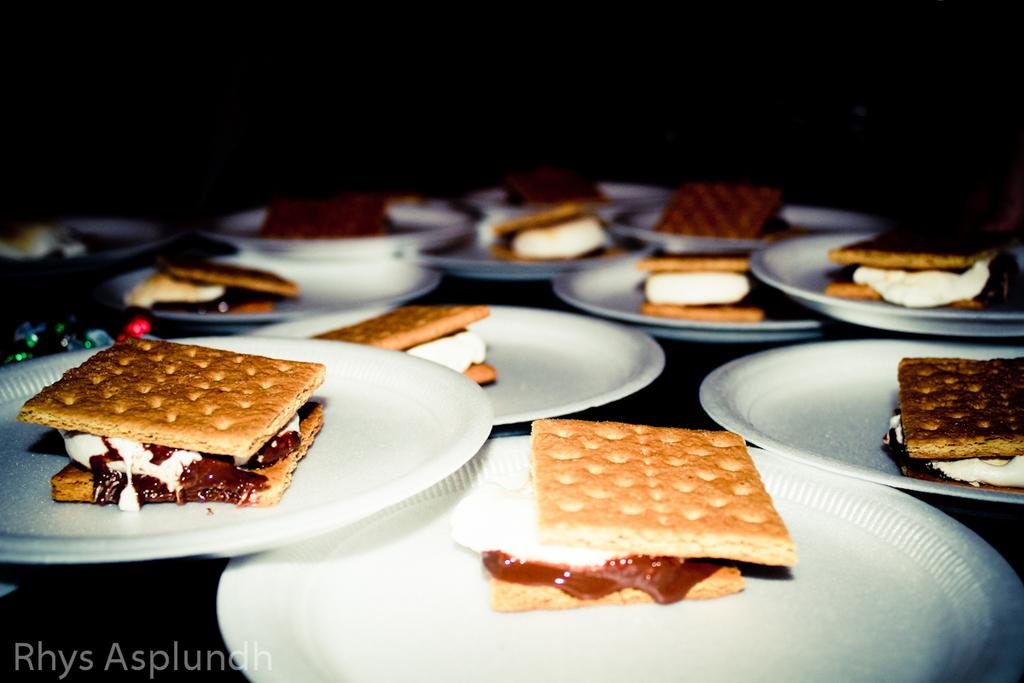What is the main object in the center of the image? There is a table in the center of the image. What is placed on the table? Planets and food items are on the table. Can you describe any additional features of the image? There is a watermark in the bottom left of the image. What direction is the bomb pointing in the image? There is no bomb present in the image. How does the harmony between the planets and food items contribute to the overall aesthetic of the image? There is no mention of harmony between the planets and food items in the image, as the focus is on their presence on the table. 